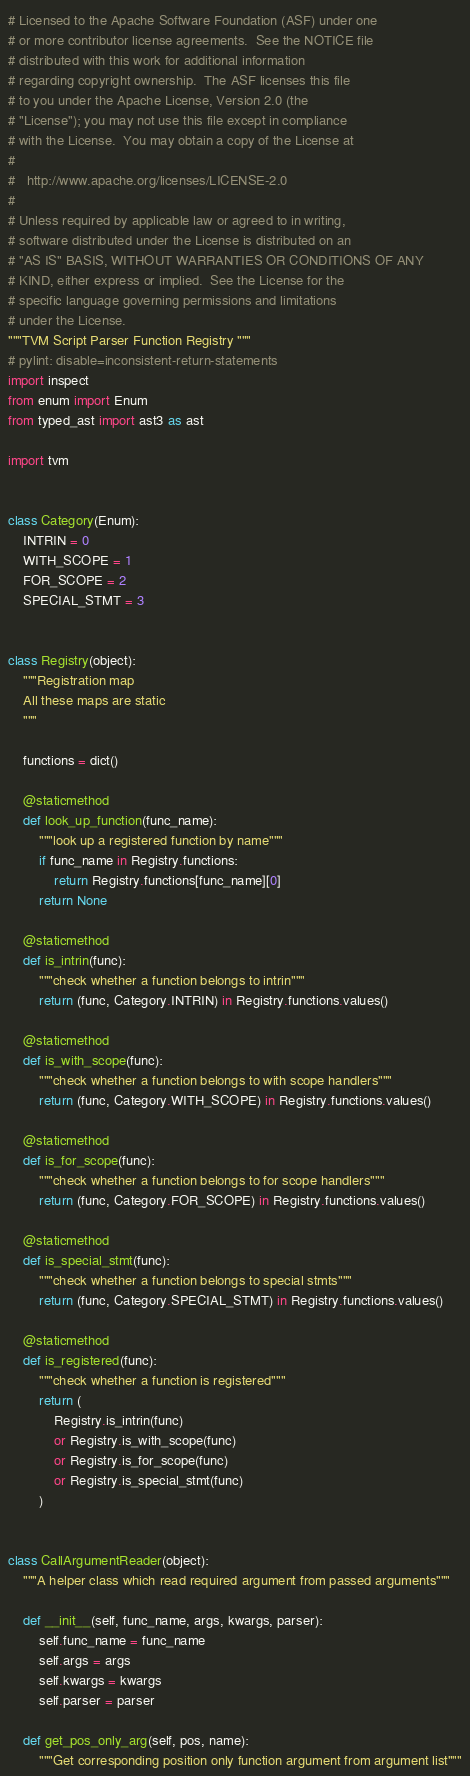Convert code to text. <code><loc_0><loc_0><loc_500><loc_500><_Python_># Licensed to the Apache Software Foundation (ASF) under one
# or more contributor license agreements.  See the NOTICE file
# distributed with this work for additional information
# regarding copyright ownership.  The ASF licenses this file
# to you under the Apache License, Version 2.0 (the
# "License"); you may not use this file except in compliance
# with the License.  You may obtain a copy of the License at
#
#   http://www.apache.org/licenses/LICENSE-2.0
#
# Unless required by applicable law or agreed to in writing,
# software distributed under the License is distributed on an
# "AS IS" BASIS, WITHOUT WARRANTIES OR CONDITIONS OF ANY
# KIND, either express or implied.  See the License for the
# specific language governing permissions and limitations
# under the License.
"""TVM Script Parser Function Registry """
# pylint: disable=inconsistent-return-statements
import inspect
from enum import Enum
from typed_ast import ast3 as ast

import tvm


class Category(Enum):
    INTRIN = 0
    WITH_SCOPE = 1
    FOR_SCOPE = 2
    SPECIAL_STMT = 3


class Registry(object):
    """Registration map
    All these maps are static
    """

    functions = dict()

    @staticmethod
    def look_up_function(func_name):
        """look up a registered function by name"""
        if func_name in Registry.functions:
            return Registry.functions[func_name][0]
        return None

    @staticmethod
    def is_intrin(func):
        """check whether a function belongs to intrin"""
        return (func, Category.INTRIN) in Registry.functions.values()

    @staticmethod
    def is_with_scope(func):
        """check whether a function belongs to with scope handlers"""
        return (func, Category.WITH_SCOPE) in Registry.functions.values()

    @staticmethod
    def is_for_scope(func):
        """check whether a function belongs to for scope handlers"""
        return (func, Category.FOR_SCOPE) in Registry.functions.values()

    @staticmethod
    def is_special_stmt(func):
        """check whether a function belongs to special stmts"""
        return (func, Category.SPECIAL_STMT) in Registry.functions.values()

    @staticmethod
    def is_registered(func):
        """check whether a function is registered"""
        return (
            Registry.is_intrin(func)
            or Registry.is_with_scope(func)
            or Registry.is_for_scope(func)
            or Registry.is_special_stmt(func)
        )


class CallArgumentReader(object):
    """A helper class which read required argument from passed arguments"""

    def __init__(self, func_name, args, kwargs, parser):
        self.func_name = func_name
        self.args = args
        self.kwargs = kwargs
        self.parser = parser

    def get_pos_only_arg(self, pos, name):
        """Get corresponding position only function argument from argument list"""</code> 